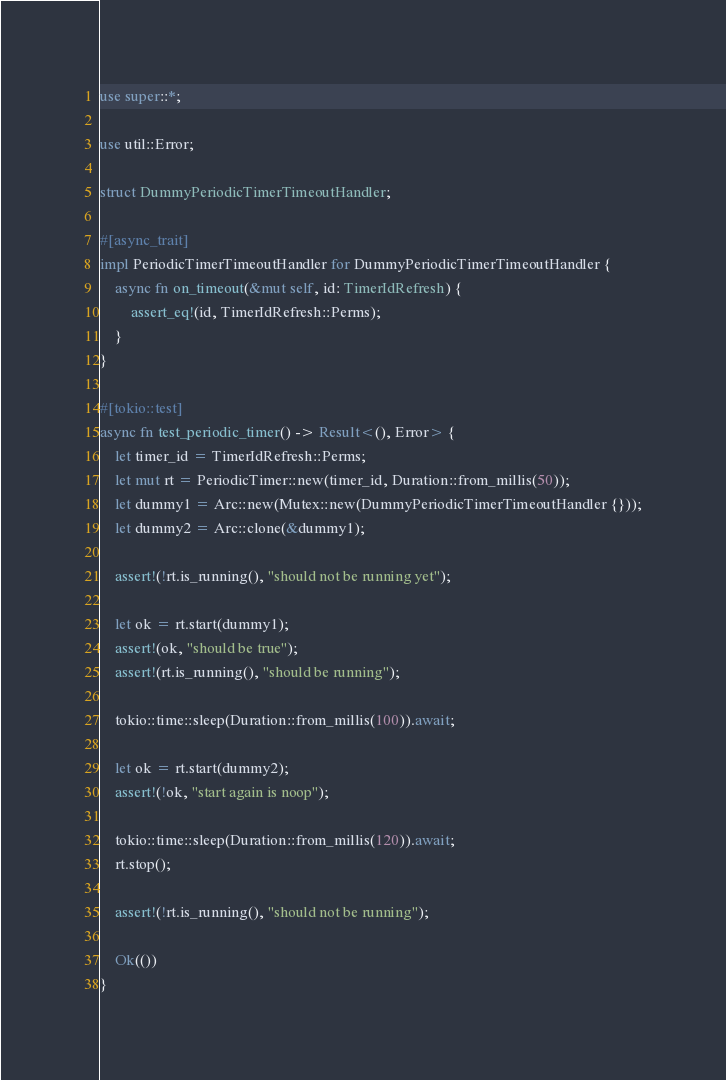<code> <loc_0><loc_0><loc_500><loc_500><_Rust_>use super::*;

use util::Error;

struct DummyPeriodicTimerTimeoutHandler;

#[async_trait]
impl PeriodicTimerTimeoutHandler for DummyPeriodicTimerTimeoutHandler {
    async fn on_timeout(&mut self, id: TimerIdRefresh) {
        assert_eq!(id, TimerIdRefresh::Perms);
    }
}

#[tokio::test]
async fn test_periodic_timer() -> Result<(), Error> {
    let timer_id = TimerIdRefresh::Perms;
    let mut rt = PeriodicTimer::new(timer_id, Duration::from_millis(50));
    let dummy1 = Arc::new(Mutex::new(DummyPeriodicTimerTimeoutHandler {}));
    let dummy2 = Arc::clone(&dummy1);

    assert!(!rt.is_running(), "should not be running yet");

    let ok = rt.start(dummy1);
    assert!(ok, "should be true");
    assert!(rt.is_running(), "should be running");

    tokio::time::sleep(Duration::from_millis(100)).await;

    let ok = rt.start(dummy2);
    assert!(!ok, "start again is noop");

    tokio::time::sleep(Duration::from_millis(120)).await;
    rt.stop();

    assert!(!rt.is_running(), "should not be running");

    Ok(())
}
</code> 